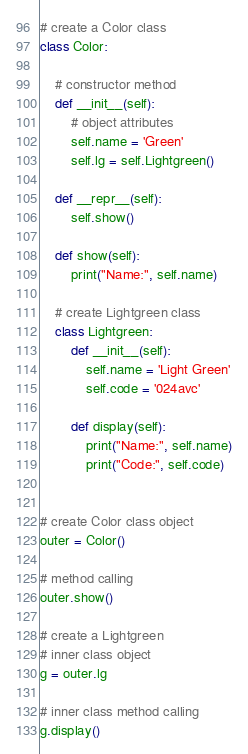Convert code to text. <code><loc_0><loc_0><loc_500><loc_500><_Python_># create a Color class
class Color:

    # constructor method
    def __init__(self):
        # object attributes
        self.name = 'Green'
        self.lg = self.Lightgreen()

    def __repr__(self):
        self.show()

    def show(self):
        print("Name:", self.name)

    # create Lightgreen class
    class Lightgreen:
        def __init__(self):
            self.name = 'Light Green'
            self.code = '024avc'

        def display(self):
            print("Name:", self.name)
            print("Code:", self.code)


# create Color class object
outer = Color()

# method calling
outer.show()

# create a Lightgreen
# inner class object
g = outer.lg

# inner class method calling
g.display()
</code> 